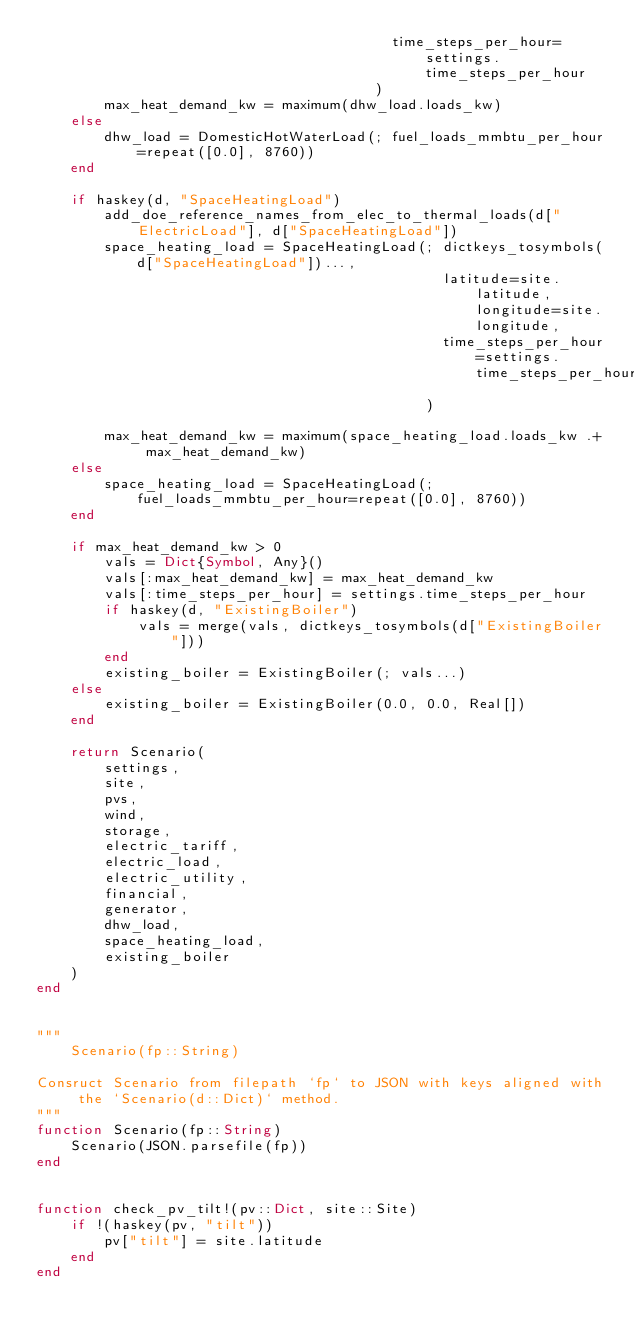Convert code to text. <code><loc_0><loc_0><loc_500><loc_500><_Julia_>                                          time_steps_per_hour=settings.time_steps_per_hour
                                        )
        max_heat_demand_kw = maximum(dhw_load.loads_kw)
    else
        dhw_load = DomesticHotWaterLoad(; fuel_loads_mmbtu_per_hour=repeat([0.0], 8760))
    end
                                    
    if haskey(d, "SpaceHeatingLoad")
        add_doe_reference_names_from_elec_to_thermal_loads(d["ElectricLoad"], d["SpaceHeatingLoad"])
        space_heating_load = SpaceHeatingLoad(; dictkeys_tosymbols(d["SpaceHeatingLoad"])...,
                                                latitude=site.latitude, longitude=site.longitude, 
                                                time_steps_per_hour=settings.time_steps_per_hour
                                              )
        
        max_heat_demand_kw = maximum(space_heating_load.loads_kw .+ max_heat_demand_kw)
    else
        space_heating_load = SpaceHeatingLoad(; fuel_loads_mmbtu_per_hour=repeat([0.0], 8760))
    end

    if max_heat_demand_kw > 0
        vals = Dict{Symbol, Any}()
        vals[:max_heat_demand_kw] = max_heat_demand_kw
        vals[:time_steps_per_hour] = settings.time_steps_per_hour
        if haskey(d, "ExistingBoiler")
            vals = merge(vals, dictkeys_tosymbols(d["ExistingBoiler"]))
        end
        existing_boiler = ExistingBoiler(; vals...)
    else
        existing_boiler = ExistingBoiler(0.0, 0.0, Real[])
    end

    return Scenario(
        settings,
        site, 
        pvs, 
        wind,
        storage, 
        electric_tariff, 
        electric_load, 
        electric_utility, 
        financial,
        generator,
        dhw_load,
        space_heating_load,
        existing_boiler
    )
end


"""
    Scenario(fp::String)

Consruct Scenario from filepath `fp` to JSON with keys aligned with the `Scenario(d::Dict)` method.
"""
function Scenario(fp::String)
    Scenario(JSON.parsefile(fp))
end


function check_pv_tilt!(pv::Dict, site::Site)
    if !(haskey(pv, "tilt"))
        pv["tilt"] = site.latitude
    end
end

</code> 